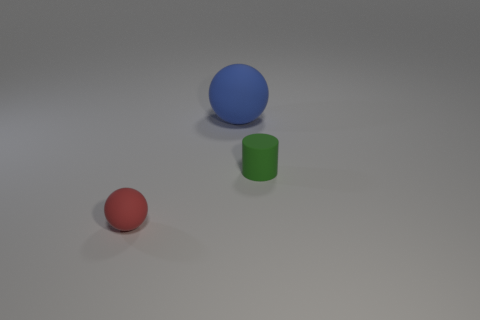Add 3 big rubber spheres. How many objects exist? 6 Subtract all spheres. How many objects are left? 1 Add 3 matte objects. How many matte objects exist? 6 Subtract 0 yellow blocks. How many objects are left? 3 Subtract all cyan balls. Subtract all matte objects. How many objects are left? 0 Add 3 tiny objects. How many tiny objects are left? 5 